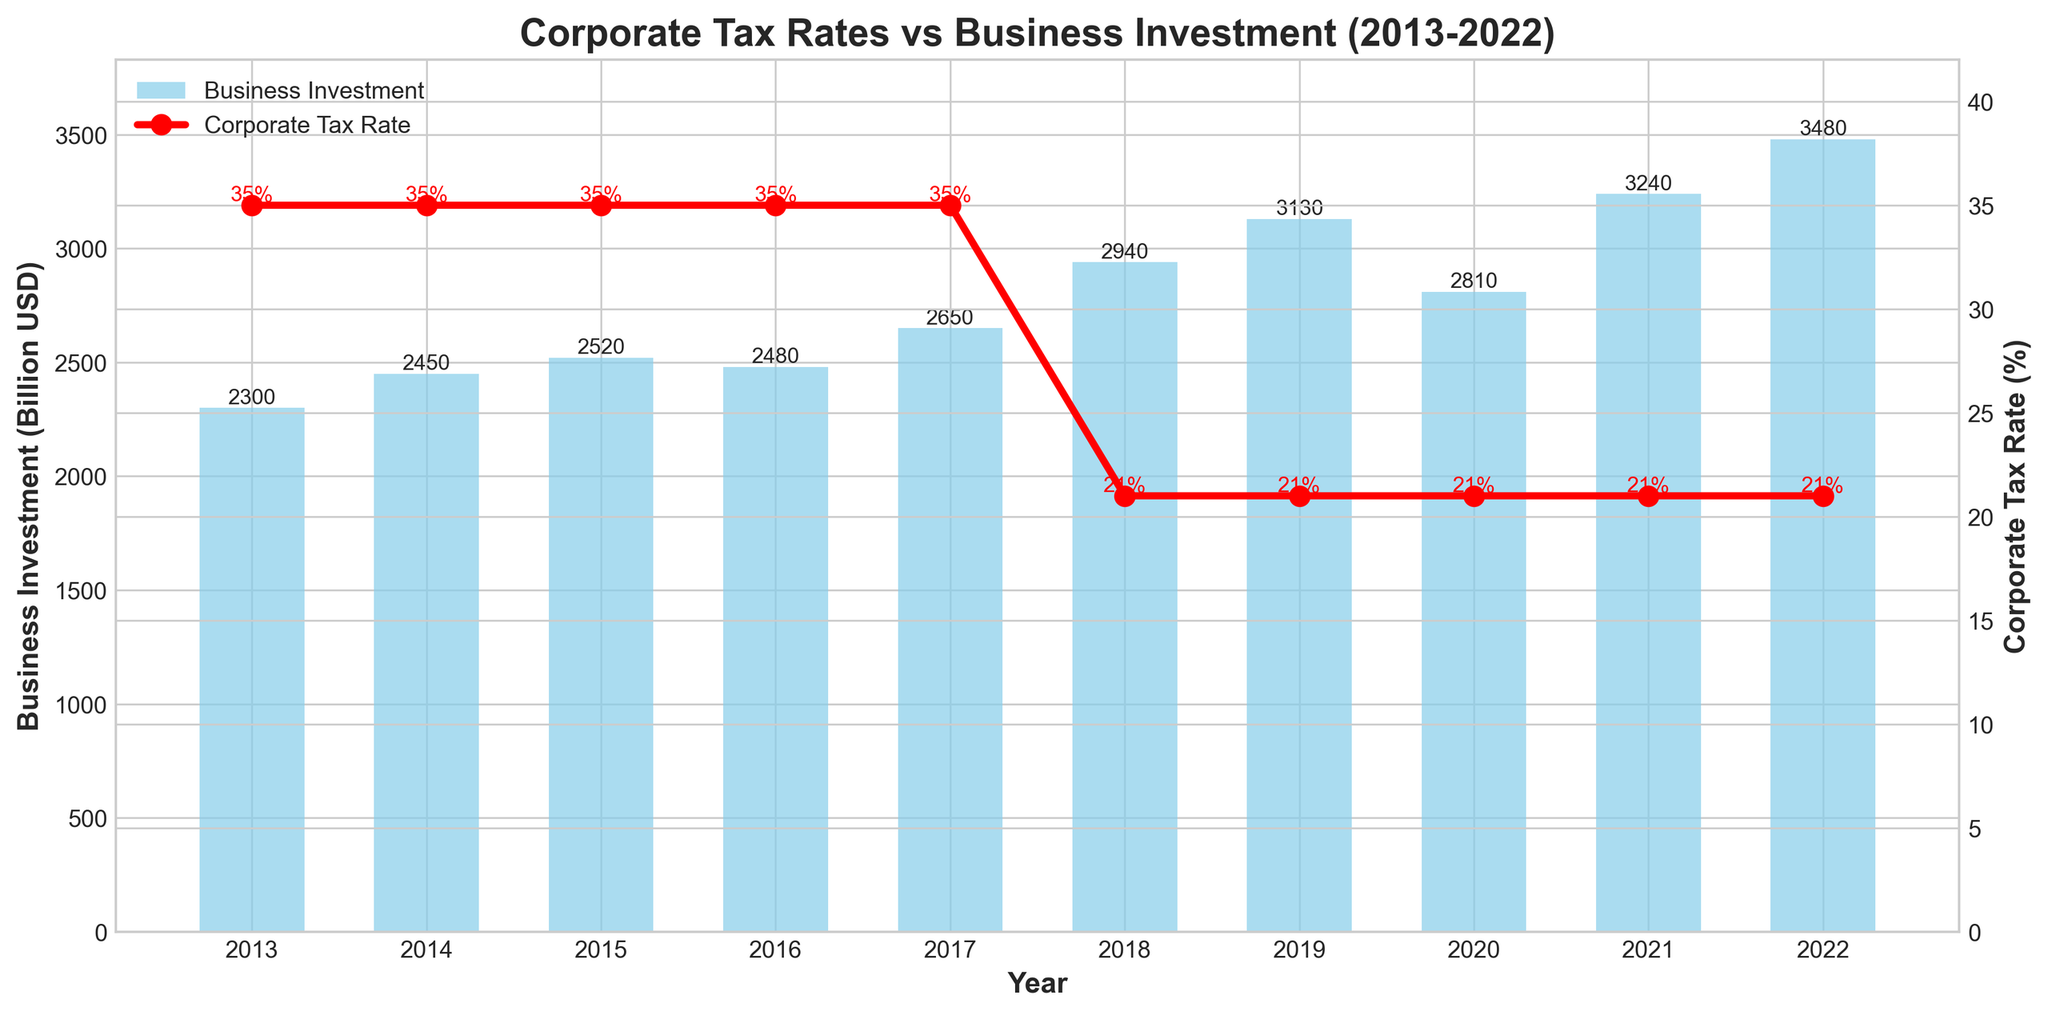What's the trend of corporate tax rates from 2013 to 2022? The corporate tax rate remained constant at 35% from 2013 to 2017. In 2018, the rate dropped to 21% and stayed at that level until 2022.
Answer: It decreased from 35% to 21% in 2018 and remained 21% In which year did business investment see the highest value and what was it? By looking at the height of the bars representing business investment, the highest bar is in 2022 with a value of 3480 billion USD.
Answer: 2022, 3480 billion USD How did business investment change from 2017 to 2018 when there was a significant drop in corporate tax rates? In 2017, business investment was 2650 billion USD. After the tax rate dropped to 21% in 2018, business investment increased to 2940 billion USD.
Answer: It increased from 2650 billion USD to 2940 billion USD Calculate the average business investment over the decade. Sum the business investment values and divide by the number of years: (2300 + 2450 + 2520 + 2480 + 2650 + 2940 + 3130 + 2810 + 3240 + 3480) / 10 = 28000 / 10 = 2800 billion USD.
Answer: 2800 billion USD Is there any year where both corporate tax rates and business investment values stayed constant? From the visual inspection, corporate tax rates were constant from 2013 to 2017 at 35%, but the business investment values were not constant. Therefore, no year had both values constant.
Answer: No What is the total increase in business investment from 2013 to 2022? The business investment in 2013 was 2300 billion USD, and in 2022 it was 3480 billion USD. The total increase is 3480 - 2300 = 1180 billion USD.
Answer: 1180 billion USD Between which consecutive years did business investment see the largest increase, and what was the increase amount? Check the differences between consecutive years' business investment values: the largest increase is between 2021 (3240) and 2022 (3480), with an increase of 3480 - 3240 = 240 billion USD.
Answer: Between 2021 and 2022, 240 billion USD Identify the years with the minimum and maximum corporate tax rates. The maximum corporate tax rate of 35% is observed from 2013 to 2017, and the minimum corporate tax rate of 21% is from 2018 to 2022.
Answer: Maximum: 2013-2017, Minimum: 2018-2022 What correlation can be observed between corporate tax rates and business investment levels from 2013 to 2022? The corporate tax rate was reduced significantly in 2018, and there seems to be an overall increase in business investment after that. This suggests an inverse correlation where the reduction in tax rates might be associated with increased business investments.
Answer: Inverse correlation: lower tax rates, higher investment 